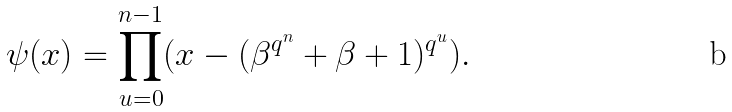<formula> <loc_0><loc_0><loc_500><loc_500>\psi ( x ) = \prod _ { u = 0 } ^ { n - 1 } ( x - ( \beta ^ { q ^ { n } } + \beta + 1 ) ^ { q ^ { u } } ) .</formula> 